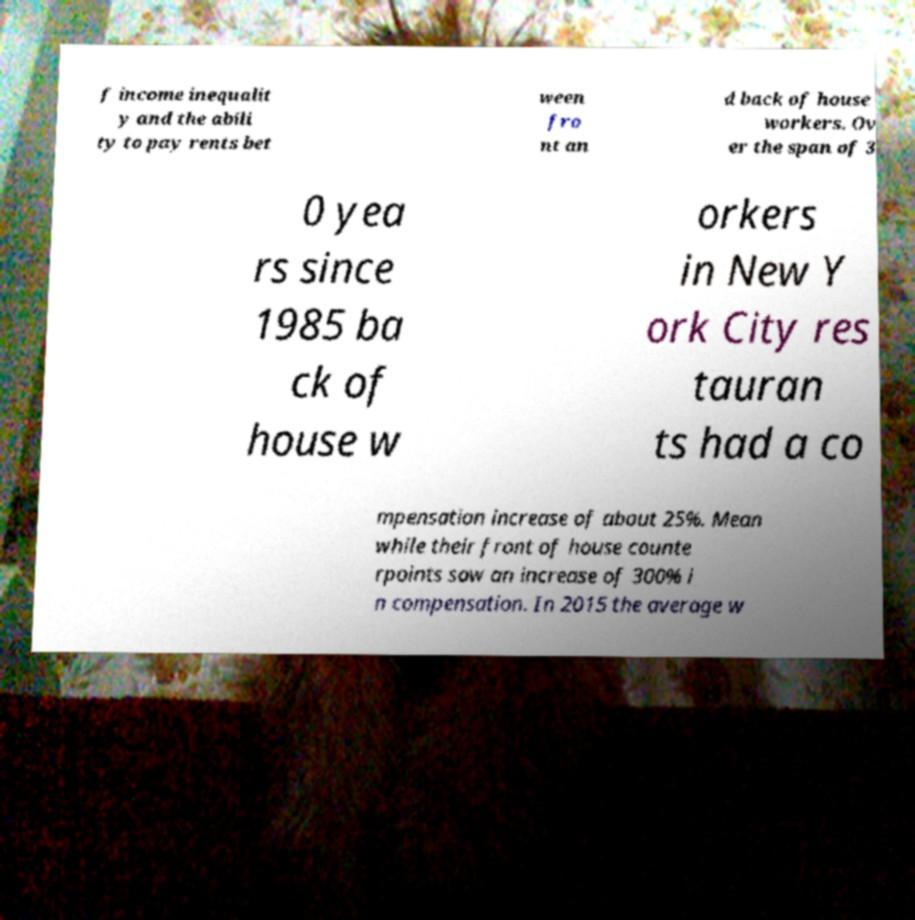Can you read and provide the text displayed in the image?This photo seems to have some interesting text. Can you extract and type it out for me? f income inequalit y and the abili ty to pay rents bet ween fro nt an d back of house workers. Ov er the span of 3 0 yea rs since 1985 ba ck of house w orkers in New Y ork City res tauran ts had a co mpensation increase of about 25%. Mean while their front of house counte rpoints saw an increase of 300% i n compensation. In 2015 the average w 